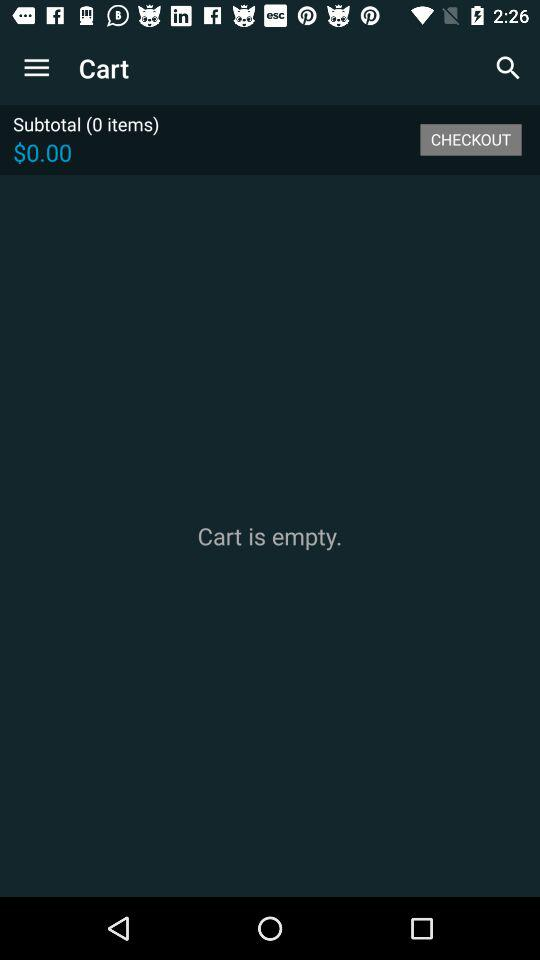What is the count of items? The count of items is 0. 